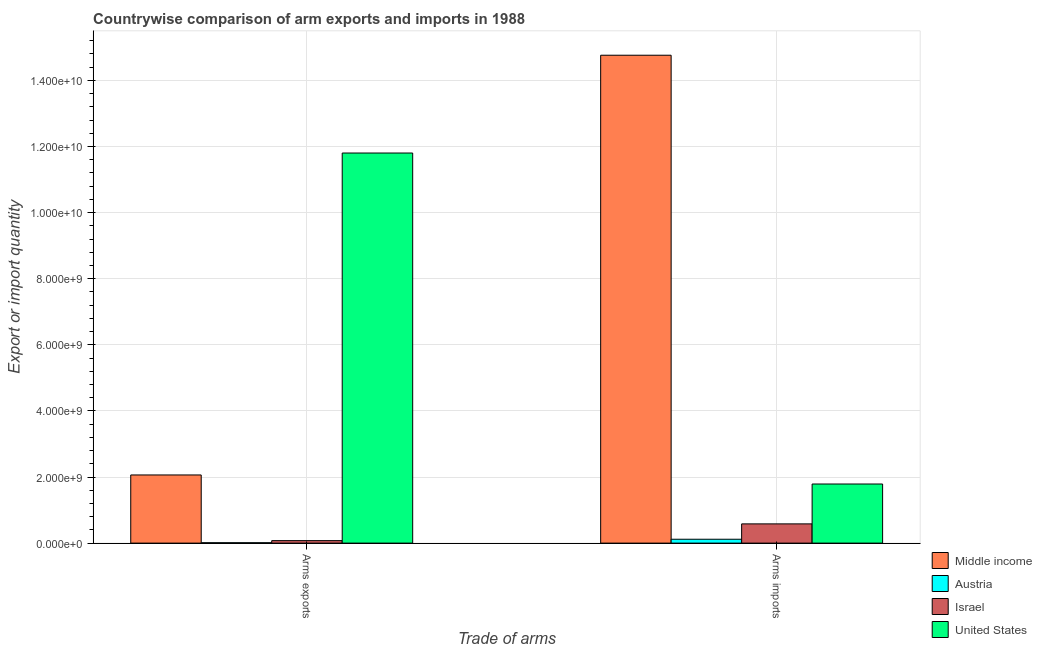How many different coloured bars are there?
Provide a short and direct response. 4. Are the number of bars on each tick of the X-axis equal?
Keep it short and to the point. Yes. How many bars are there on the 2nd tick from the left?
Your response must be concise. 4. What is the label of the 2nd group of bars from the left?
Give a very brief answer. Arms imports. What is the arms imports in United States?
Your answer should be compact. 1.79e+09. Across all countries, what is the maximum arms exports?
Keep it short and to the point. 1.18e+1. Across all countries, what is the minimum arms exports?
Your answer should be very brief. 1.20e+07. In which country was the arms imports minimum?
Provide a short and direct response. Austria. What is the total arms exports in the graph?
Keep it short and to the point. 1.40e+1. What is the difference between the arms exports in United States and that in Austria?
Provide a succinct answer. 1.18e+1. What is the difference between the arms imports in United States and the arms exports in Austria?
Keep it short and to the point. 1.78e+09. What is the average arms imports per country?
Ensure brevity in your answer.  4.31e+09. What is the difference between the arms imports and arms exports in Middle income?
Offer a very short reply. 1.27e+1. In how many countries, is the arms imports greater than 400000000 ?
Offer a terse response. 3. What is the ratio of the arms exports in Israel to that in United States?
Your answer should be compact. 0.01. Is the arms imports in United States less than that in Austria?
Give a very brief answer. No. What does the 1st bar from the left in Arms exports represents?
Provide a succinct answer. Middle income. What does the 2nd bar from the right in Arms exports represents?
Provide a succinct answer. Israel. Are the values on the major ticks of Y-axis written in scientific E-notation?
Offer a very short reply. Yes. Does the graph contain any zero values?
Ensure brevity in your answer.  No. Where does the legend appear in the graph?
Offer a very short reply. Bottom right. How many legend labels are there?
Your answer should be very brief. 4. What is the title of the graph?
Provide a succinct answer. Countrywise comparison of arm exports and imports in 1988. Does "Israel" appear as one of the legend labels in the graph?
Keep it short and to the point. Yes. What is the label or title of the X-axis?
Your response must be concise. Trade of arms. What is the label or title of the Y-axis?
Keep it short and to the point. Export or import quantity. What is the Export or import quantity in Middle income in Arms exports?
Keep it short and to the point. 2.06e+09. What is the Export or import quantity of Austria in Arms exports?
Your answer should be compact. 1.20e+07. What is the Export or import quantity in Israel in Arms exports?
Your answer should be compact. 7.50e+07. What is the Export or import quantity in United States in Arms exports?
Provide a short and direct response. 1.18e+1. What is the Export or import quantity of Middle income in Arms imports?
Your response must be concise. 1.48e+1. What is the Export or import quantity of Austria in Arms imports?
Your answer should be very brief. 1.17e+08. What is the Export or import quantity in Israel in Arms imports?
Your answer should be compact. 5.82e+08. What is the Export or import quantity of United States in Arms imports?
Offer a very short reply. 1.79e+09. Across all Trade of arms, what is the maximum Export or import quantity of Middle income?
Provide a succinct answer. 1.48e+1. Across all Trade of arms, what is the maximum Export or import quantity of Austria?
Offer a very short reply. 1.17e+08. Across all Trade of arms, what is the maximum Export or import quantity in Israel?
Offer a very short reply. 5.82e+08. Across all Trade of arms, what is the maximum Export or import quantity of United States?
Provide a succinct answer. 1.18e+1. Across all Trade of arms, what is the minimum Export or import quantity of Middle income?
Make the answer very short. 2.06e+09. Across all Trade of arms, what is the minimum Export or import quantity in Austria?
Offer a very short reply. 1.20e+07. Across all Trade of arms, what is the minimum Export or import quantity in Israel?
Your answer should be very brief. 7.50e+07. Across all Trade of arms, what is the minimum Export or import quantity of United States?
Offer a very short reply. 1.79e+09. What is the total Export or import quantity in Middle income in the graph?
Your answer should be compact. 1.68e+1. What is the total Export or import quantity in Austria in the graph?
Ensure brevity in your answer.  1.29e+08. What is the total Export or import quantity in Israel in the graph?
Provide a succinct answer. 6.57e+08. What is the total Export or import quantity of United States in the graph?
Ensure brevity in your answer.  1.36e+1. What is the difference between the Export or import quantity in Middle income in Arms exports and that in Arms imports?
Give a very brief answer. -1.27e+1. What is the difference between the Export or import quantity of Austria in Arms exports and that in Arms imports?
Offer a very short reply. -1.05e+08. What is the difference between the Export or import quantity in Israel in Arms exports and that in Arms imports?
Your answer should be compact. -5.07e+08. What is the difference between the Export or import quantity in United States in Arms exports and that in Arms imports?
Ensure brevity in your answer.  1.00e+1. What is the difference between the Export or import quantity in Middle income in Arms exports and the Export or import quantity in Austria in Arms imports?
Keep it short and to the point. 1.94e+09. What is the difference between the Export or import quantity of Middle income in Arms exports and the Export or import quantity of Israel in Arms imports?
Keep it short and to the point. 1.48e+09. What is the difference between the Export or import quantity of Middle income in Arms exports and the Export or import quantity of United States in Arms imports?
Your answer should be compact. 2.74e+08. What is the difference between the Export or import quantity of Austria in Arms exports and the Export or import quantity of Israel in Arms imports?
Make the answer very short. -5.70e+08. What is the difference between the Export or import quantity in Austria in Arms exports and the Export or import quantity in United States in Arms imports?
Ensure brevity in your answer.  -1.78e+09. What is the difference between the Export or import quantity in Israel in Arms exports and the Export or import quantity in United States in Arms imports?
Give a very brief answer. -1.71e+09. What is the average Export or import quantity of Middle income per Trade of arms?
Your response must be concise. 8.41e+09. What is the average Export or import quantity in Austria per Trade of arms?
Provide a short and direct response. 6.45e+07. What is the average Export or import quantity of Israel per Trade of arms?
Give a very brief answer. 3.28e+08. What is the average Export or import quantity of United States per Trade of arms?
Offer a very short reply. 6.79e+09. What is the difference between the Export or import quantity in Middle income and Export or import quantity in Austria in Arms exports?
Your answer should be very brief. 2.05e+09. What is the difference between the Export or import quantity of Middle income and Export or import quantity of Israel in Arms exports?
Your answer should be very brief. 1.99e+09. What is the difference between the Export or import quantity of Middle income and Export or import quantity of United States in Arms exports?
Your answer should be very brief. -9.74e+09. What is the difference between the Export or import quantity in Austria and Export or import quantity in Israel in Arms exports?
Provide a short and direct response. -6.30e+07. What is the difference between the Export or import quantity in Austria and Export or import quantity in United States in Arms exports?
Offer a terse response. -1.18e+1. What is the difference between the Export or import quantity in Israel and Export or import quantity in United States in Arms exports?
Your answer should be very brief. -1.17e+1. What is the difference between the Export or import quantity in Middle income and Export or import quantity in Austria in Arms imports?
Your response must be concise. 1.46e+1. What is the difference between the Export or import quantity in Middle income and Export or import quantity in Israel in Arms imports?
Your answer should be very brief. 1.42e+1. What is the difference between the Export or import quantity of Middle income and Export or import quantity of United States in Arms imports?
Provide a succinct answer. 1.30e+1. What is the difference between the Export or import quantity of Austria and Export or import quantity of Israel in Arms imports?
Provide a succinct answer. -4.65e+08. What is the difference between the Export or import quantity in Austria and Export or import quantity in United States in Arms imports?
Make the answer very short. -1.67e+09. What is the difference between the Export or import quantity in Israel and Export or import quantity in United States in Arms imports?
Your answer should be compact. -1.21e+09. What is the ratio of the Export or import quantity of Middle income in Arms exports to that in Arms imports?
Your answer should be compact. 0.14. What is the ratio of the Export or import quantity of Austria in Arms exports to that in Arms imports?
Provide a short and direct response. 0.1. What is the ratio of the Export or import quantity in Israel in Arms exports to that in Arms imports?
Give a very brief answer. 0.13. What is the ratio of the Export or import quantity of United States in Arms exports to that in Arms imports?
Offer a terse response. 6.6. What is the difference between the highest and the second highest Export or import quantity of Middle income?
Your response must be concise. 1.27e+1. What is the difference between the highest and the second highest Export or import quantity in Austria?
Ensure brevity in your answer.  1.05e+08. What is the difference between the highest and the second highest Export or import quantity of Israel?
Offer a very short reply. 5.07e+08. What is the difference between the highest and the second highest Export or import quantity of United States?
Your answer should be compact. 1.00e+1. What is the difference between the highest and the lowest Export or import quantity in Middle income?
Your answer should be compact. 1.27e+1. What is the difference between the highest and the lowest Export or import quantity of Austria?
Offer a very short reply. 1.05e+08. What is the difference between the highest and the lowest Export or import quantity in Israel?
Give a very brief answer. 5.07e+08. What is the difference between the highest and the lowest Export or import quantity of United States?
Ensure brevity in your answer.  1.00e+1. 